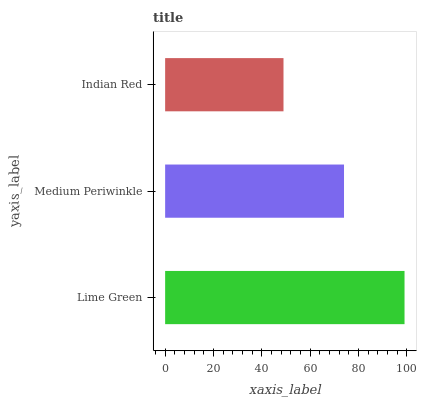Is Indian Red the minimum?
Answer yes or no. Yes. Is Lime Green the maximum?
Answer yes or no. Yes. Is Medium Periwinkle the minimum?
Answer yes or no. No. Is Medium Periwinkle the maximum?
Answer yes or no. No. Is Lime Green greater than Medium Periwinkle?
Answer yes or no. Yes. Is Medium Periwinkle less than Lime Green?
Answer yes or no. Yes. Is Medium Periwinkle greater than Lime Green?
Answer yes or no. No. Is Lime Green less than Medium Periwinkle?
Answer yes or no. No. Is Medium Periwinkle the high median?
Answer yes or no. Yes. Is Medium Periwinkle the low median?
Answer yes or no. Yes. Is Lime Green the high median?
Answer yes or no. No. Is Indian Red the low median?
Answer yes or no. No. 